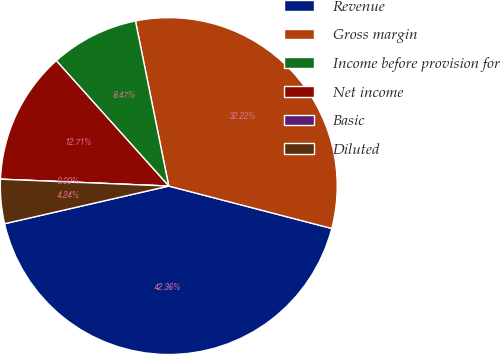Convert chart to OTSL. <chart><loc_0><loc_0><loc_500><loc_500><pie_chart><fcel>Revenue<fcel>Gross margin<fcel>Income before provision for<fcel>Net income<fcel>Basic<fcel>Diluted<nl><fcel>42.36%<fcel>32.22%<fcel>8.47%<fcel>12.71%<fcel>0.0%<fcel>4.24%<nl></chart> 